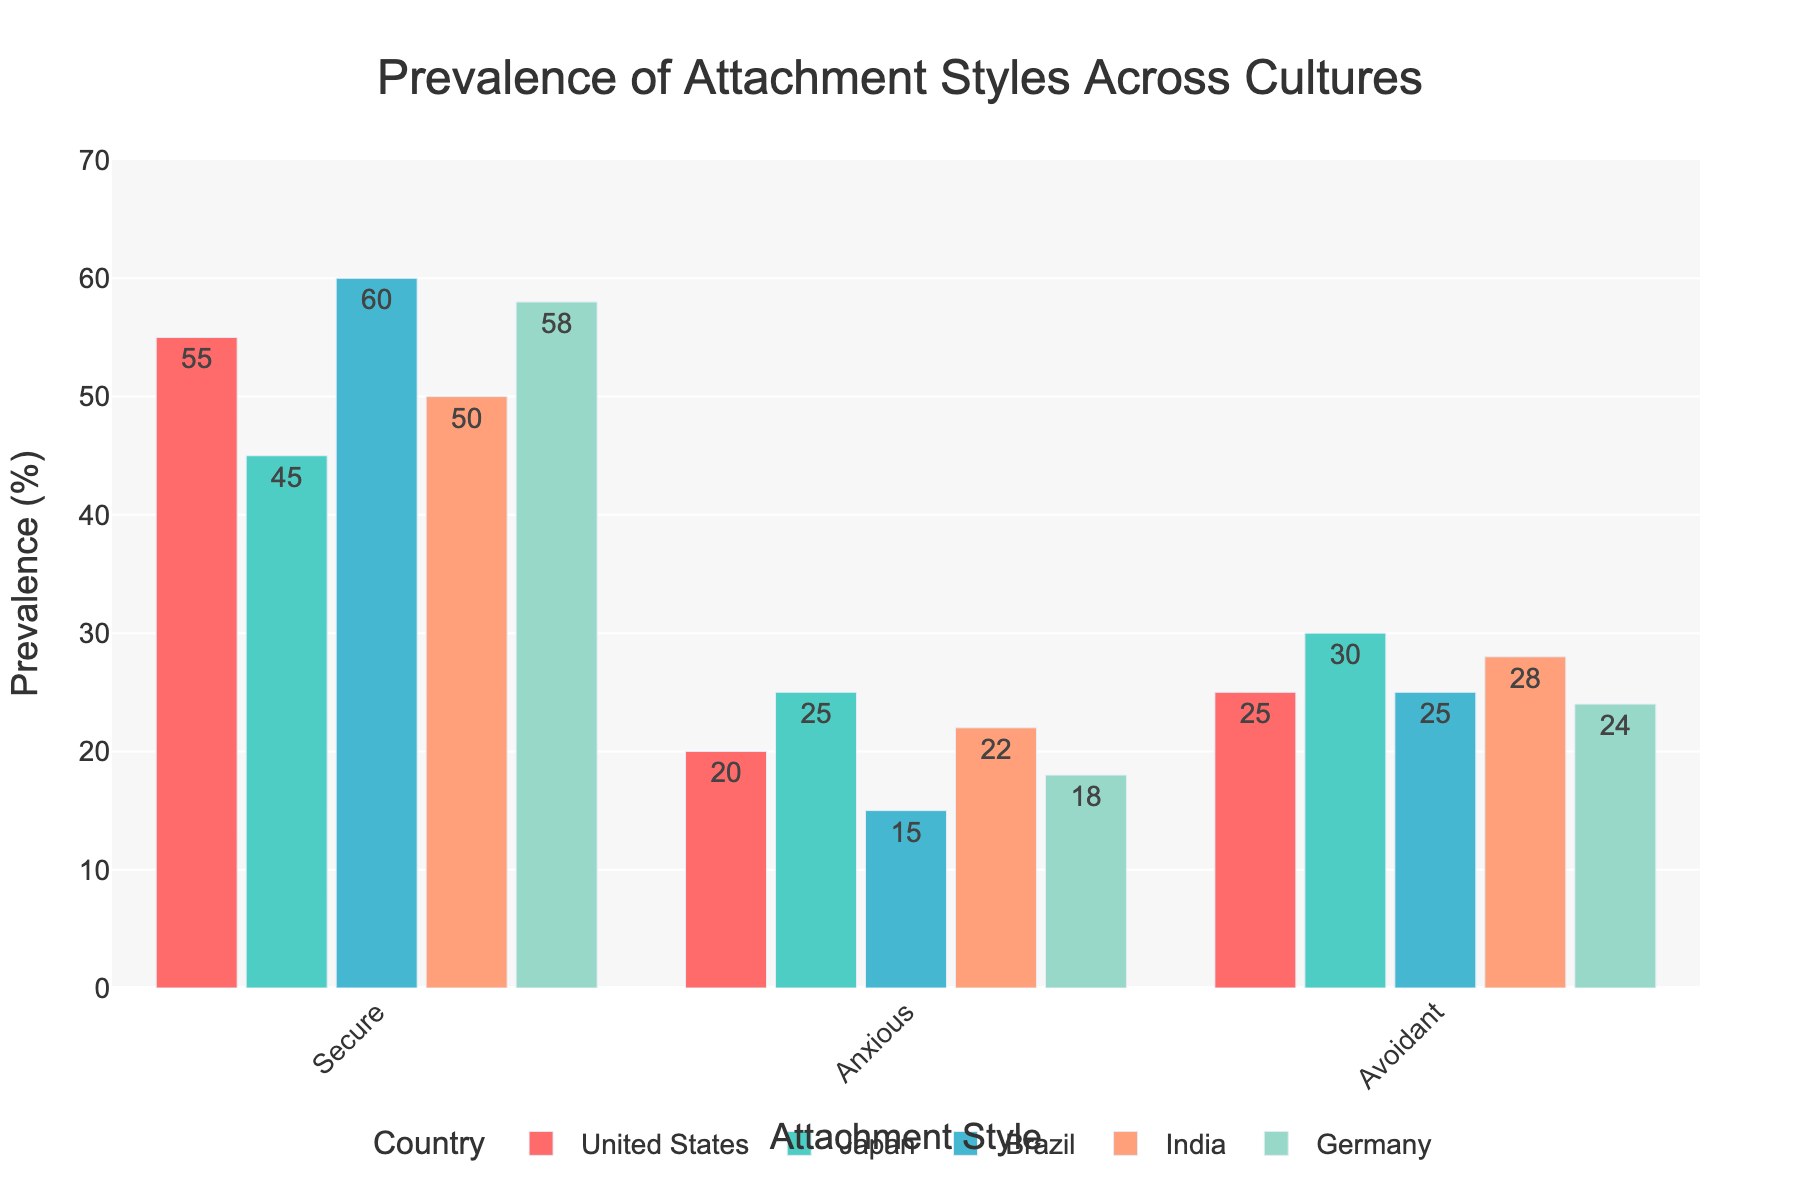What's the most common attachment style in the United States? The highest bar representing the United States is for the "Secure" attachment style.
Answer: Secure Which country has the highest prevalence of the Anxious attachment style? The tallest bar under the Anxious attachment style is for Japan.
Answer: Japan What is the difference in prevalence of the Avoidant attachment style between India and the United States? The bar heights for India and the United States under the Avoidant attachment style are 28 and 25, respectively. The difference is 28 - 25 = 3.
Answer: 3 Rank the countries by the prevalence of the Secure attachment style, from highest to lowest. The Secure attachment style values across countries are: Brazil (60), Germany (58), United States (55), India (50), Japan (45).
Answer: Brazil, Germany, United States, India, Japan Which country has the most balanced distribution of attachment styles? Inspecting the lengths of bars for each country, the values for Secure, Anxious, and Avoidant in the United States (55, 20, 25) are the closest to each other overall.
Answer: United States What is the average prevalence of the Secure attachment style across all countries? Add the percentages for the Secure attachment style (55 + 45 + 60 + 50 + 58) and divide by the number of countries (5). The calculation is (55 + 45 + 60 + 50 + 58) / 5 = 53.6.
Answer: 53.6 By how much does the prevalence of the Avoidant attachment style in Germany exceed that in Japan? The bar heights for Germany and Japan under the Avoidant attachment style are 24 and 30, respectively. The difference is 30 - 24 = 6.
Answer: 6 Which country shows the lowest overall prevalence of attachment styles other than Secure? To find this, look for the country with the lowest combined bar heights of Anxious and Avoidant, which is Brazil with (15 Anxious + 25 Avoidant) = 40.
Answer: Brazil For which country does the Anxious attachment style almost equally compare to the Avoidant attachment style? Checking the values, Japan has 25 for the Anxious style and 30 for the Avoidant style, which are nearly equal.
Answer: Japan What is the combined prevalence of the Secure and Avoidant attachment styles in India? Add the values for Secure (50) and Avoidant (28), resulting in 50 + 28 = 78.
Answer: 78 